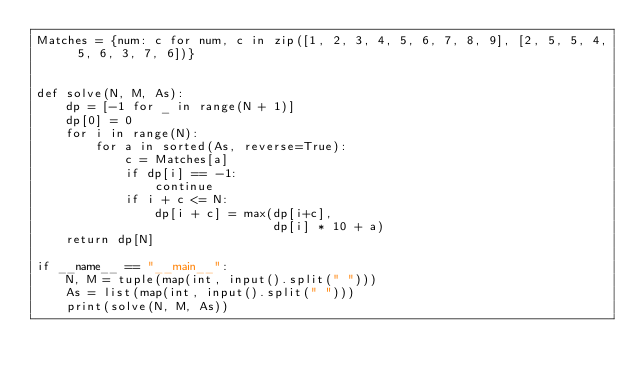Convert code to text. <code><loc_0><loc_0><loc_500><loc_500><_Python_>Matches = {num: c for num, c in zip([1, 2, 3, 4, 5, 6, 7, 8, 9], [2, 5, 5, 4, 5, 6, 3, 7, 6])}


def solve(N, M, As):
    dp = [-1 for _ in range(N + 1)]
    dp[0] = 0
    for i in range(N):
        for a in sorted(As, reverse=True):
            c = Matches[a]
            if dp[i] == -1:
                continue
            if i + c <= N:
                dp[i + c] = max(dp[i+c],
                                dp[i] * 10 + a)
    return dp[N]

if __name__ == "__main__":
    N, M = tuple(map(int, input().split(" ")))
    As = list(map(int, input().split(" ")))
    print(solve(N, M, As))
</code> 